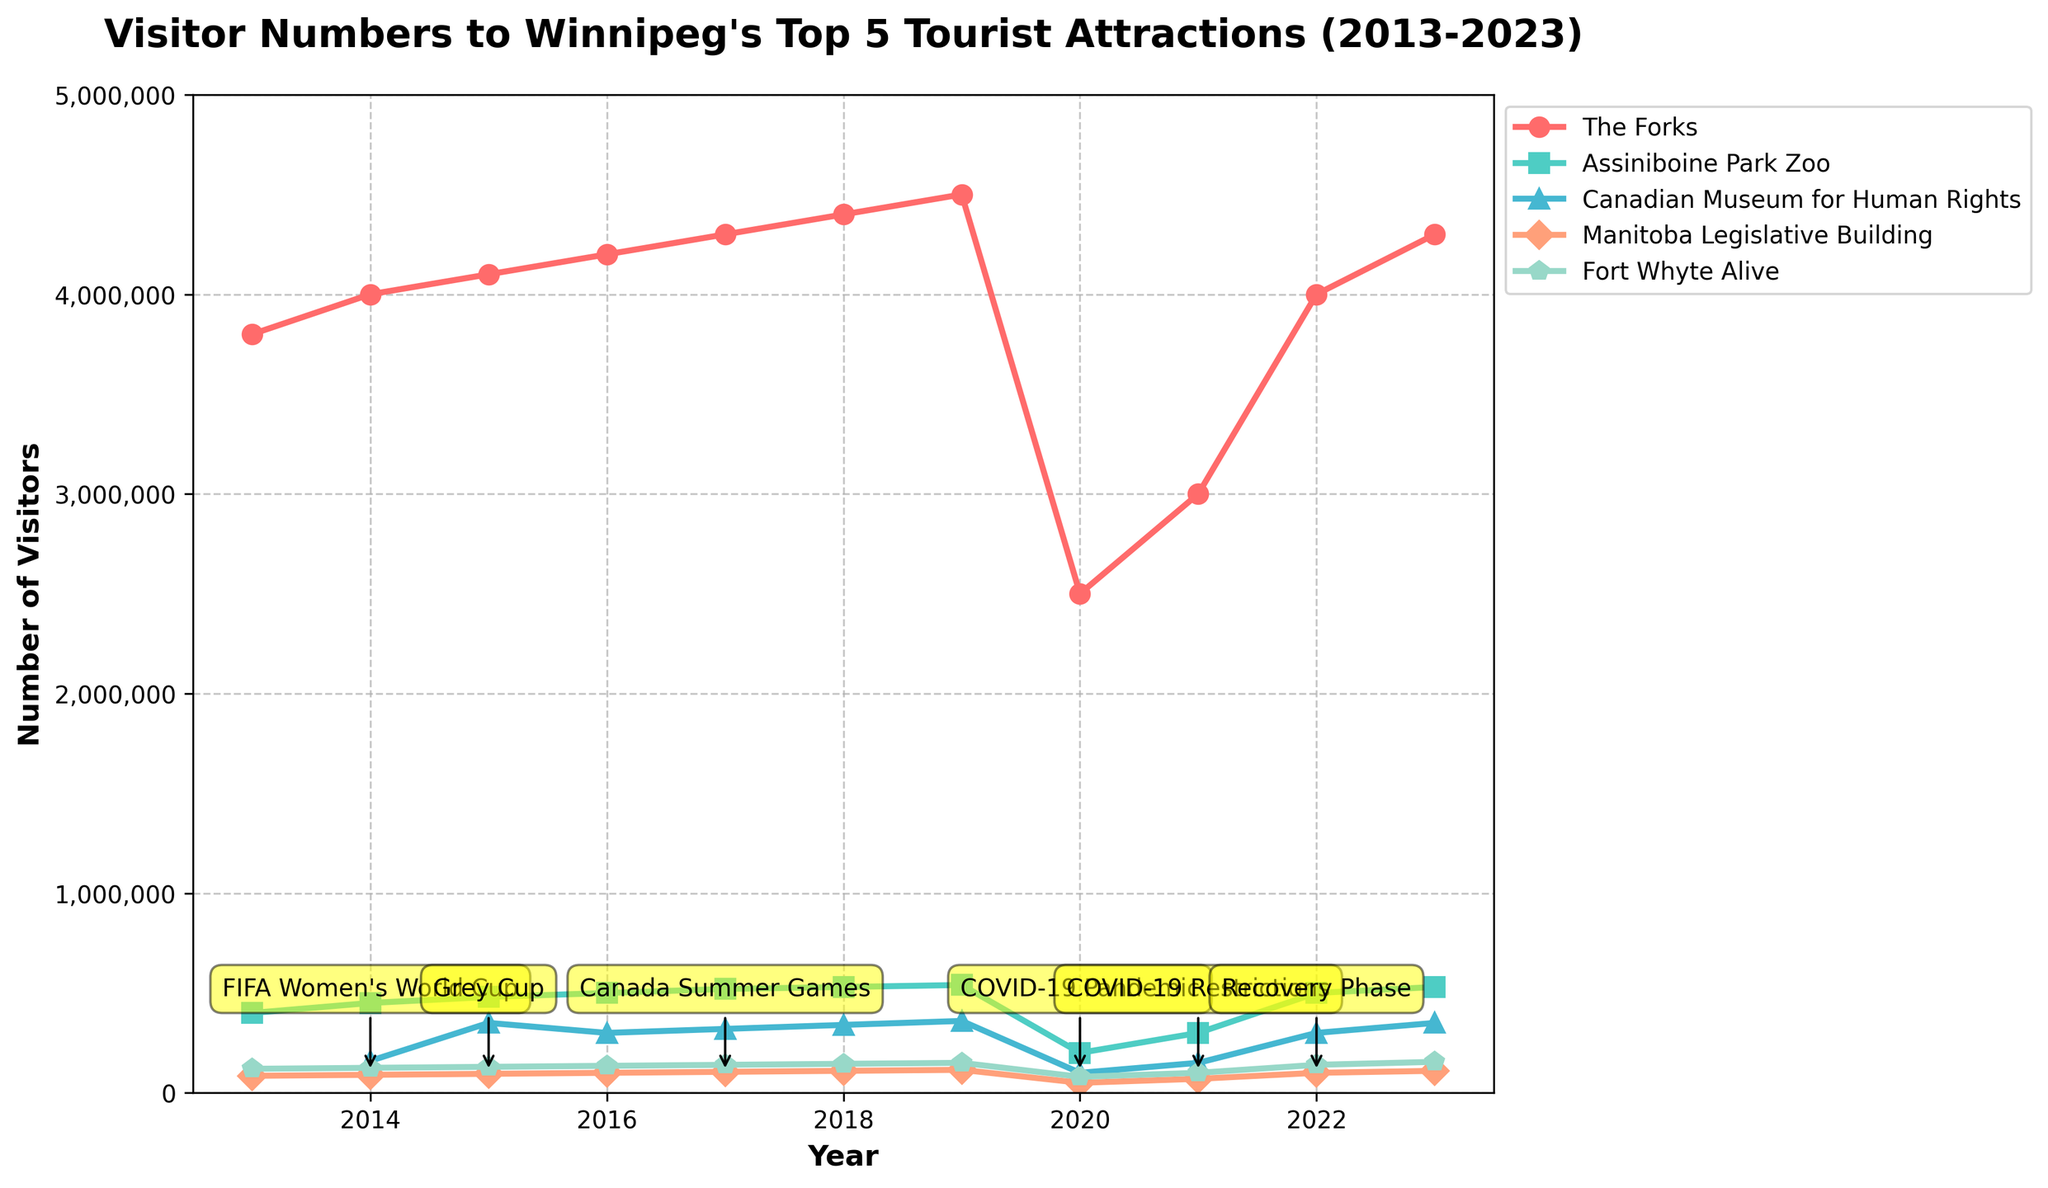What was the impact of the COVID-19 pandemic on visitor numbers in 2020 compared to 2019? Compare the visitor numbers for each attraction from 2019 and 2020. For example, The Forks had 4,500,000 visitors in 2019 and 2,500,000 in 2020, a decrease of 2,000,000 visitors. Similar decreases can be observed for other attractions.
Answer: Major decrease Which tourist attraction had the highest number of visitors in 2023? Refer to the chart for 2023 and identify the peak of the lines for each attraction. The Forks has the highest number with 4,300,000 visitors.
Answer: The Forks How did the visitor numbers of the Canadian Museum for Human Rights change from 2014 to 2015? Look at the line representing the Canadian Museum for Human Rights and compare the data points for 2014 and 2015. The number rose from 160,000 in 2014 to 350,000 in 2015, an increase of 190,000.
Answer: Increased by 190,000 Between which years did Assiniboine Park Zoo see the highest increase in visitor numbers? Review the yearly data points of Assiniboine Park Zoo and note the increases. The highest increase occurred between 2013 (400,000 visitors) and 2014 (450,000 visitors), an increase of 50,000 visitors.
Answer: 2013-2014 What was the average number of visitors to Fort Whyte Alive from 2021 to 2023? Add up the visitor numbers for Fort Whyte Alive from 2021 (100,000), 2022 (140,000), and 2023 (155,000). The total is 395,000. Divide by 3 for the average: 395,000 / 3 ≈ 131,667.
Answer: Approximately 131,667 Was there any major event that correlated with an increase in visitor numbers for The Forks? If so, specify which event(s). Identify any spike in visitor numbers for The Forks and then check which years had major events. Notably, 2022 experienced a significant increase during the Recovery Phase after COVID-19 restrictions.
Answer: Recovery Phase Which year saw the steepest decline in visitor numbers for the Manitoba Legislative Building? Examine the slope of the line for the Manitoba Legislative Building. The steepest decline is from 2019 to 2020, coinciding with the COVID-19 pandemic, dropping from 115,000 to 50,000.
Answer: 2019-2020 Compare the recovery of visitor numbers in 2022 for the attractions impacted by the COVID-19 pandemic. Did all attractions recover to their pre-pandemic levels? Analyze the visitor numbers in 2022 and compare them with numbers before 2020. The Forks, Assiniboine Park Zoo, and Fort Whyte Alive nearly returned to pre-pandemic levels, while the Canadian Museum for Human Rights and Manitoba Legislative Building showed partial recovery.
Answer: Partial recovery 